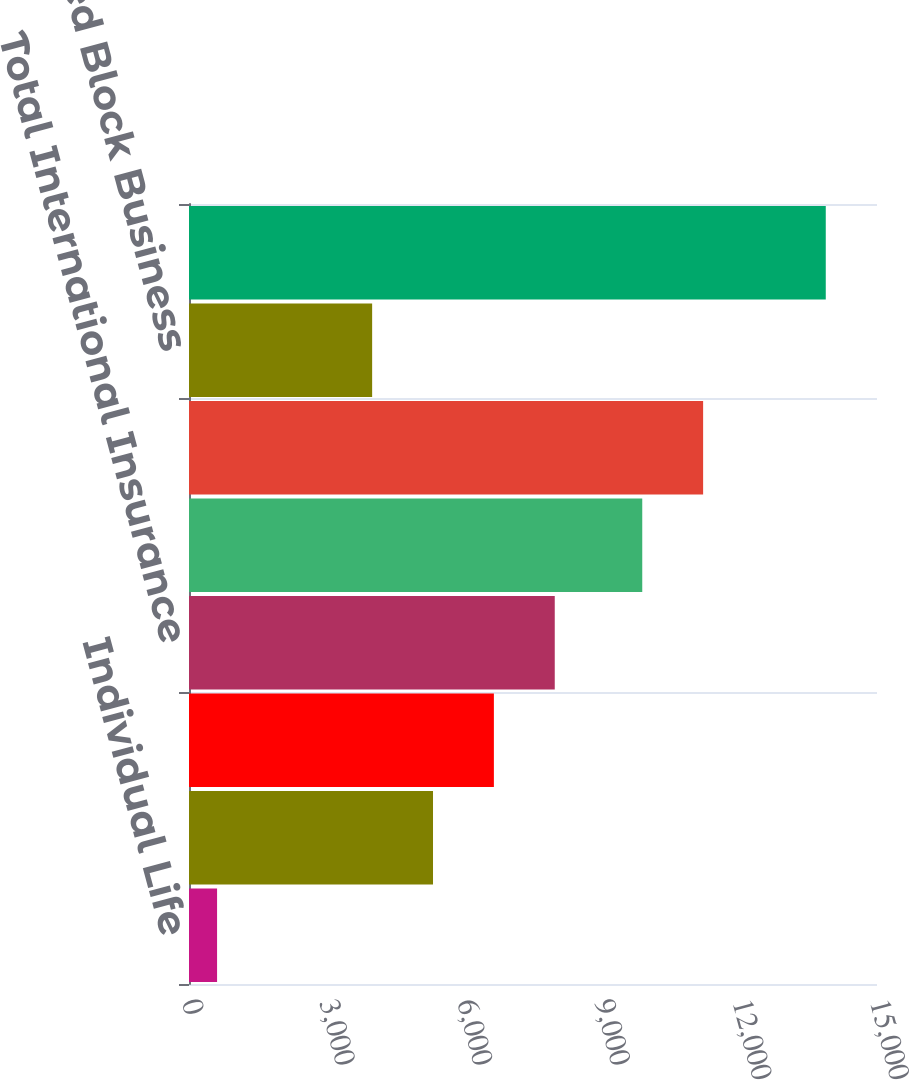Convert chart to OTSL. <chart><loc_0><loc_0><loc_500><loc_500><bar_chart><fcel>Individual Life<fcel>Total Insurance Division<fcel>International Insurance<fcel>Total International Insurance<fcel>Total<fcel>Total Financial Services<fcel>Closed Block Business<fcel>Total per Consolidated<nl><fcel>612<fcel>5320.1<fcel>6647.2<fcel>7974.3<fcel>9882<fcel>11209.1<fcel>3993<fcel>13883<nl></chart> 